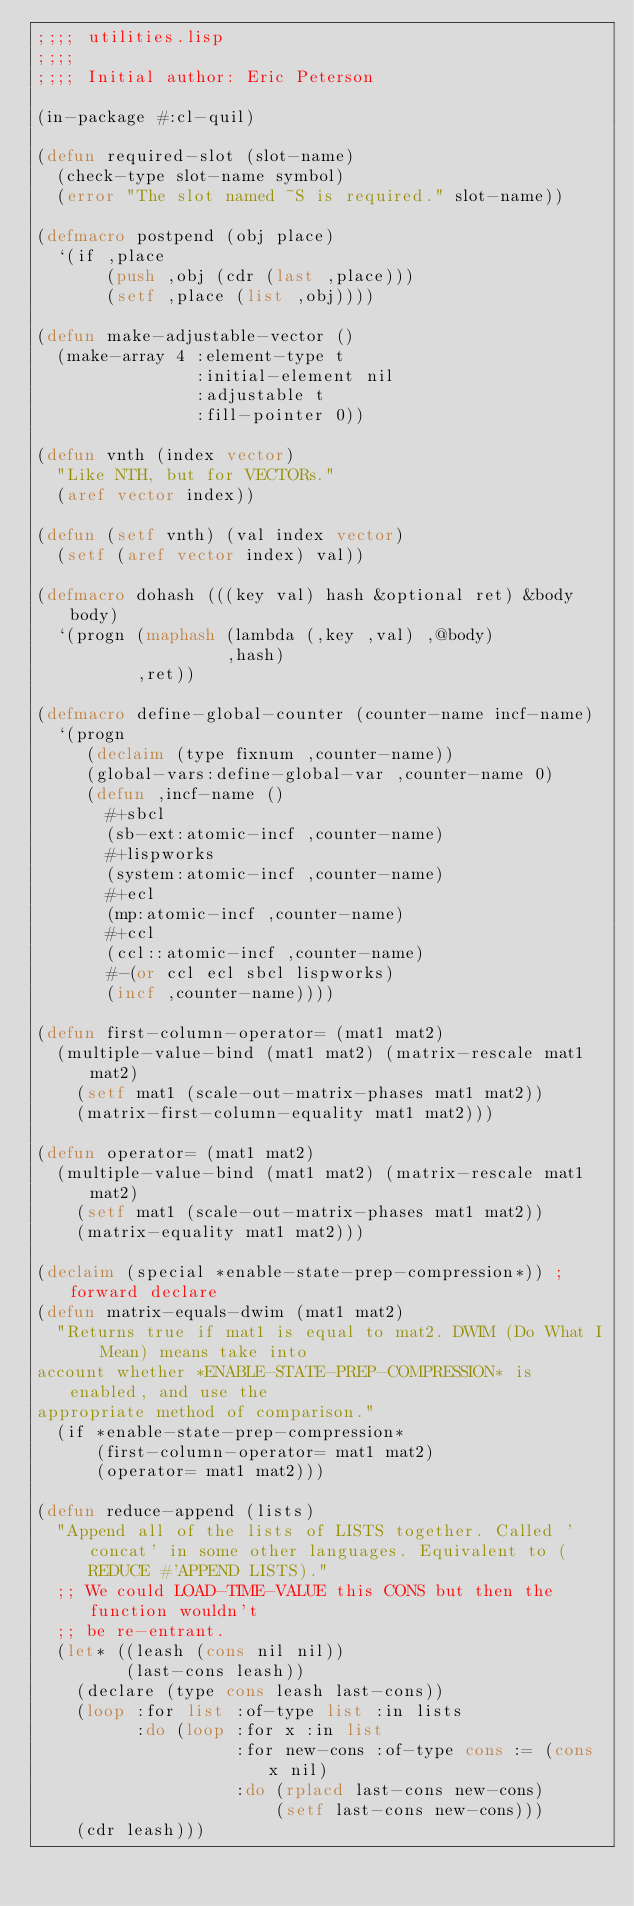<code> <loc_0><loc_0><loc_500><loc_500><_Lisp_>;;;; utilities.lisp
;;;;
;;;; Initial author: Eric Peterson

(in-package #:cl-quil)

(defun required-slot (slot-name)
  (check-type slot-name symbol)
  (error "The slot named ~S is required." slot-name))

(defmacro postpend (obj place)
  `(if ,place
       (push ,obj (cdr (last ,place)))
       (setf ,place (list ,obj))))

(defun make-adjustable-vector ()
  (make-array 4 :element-type t
                :initial-element nil
                :adjustable t
                :fill-pointer 0))

(defun vnth (index vector)
  "Like NTH, but for VECTORs."
  (aref vector index))

(defun (setf vnth) (val index vector)
  (setf (aref vector index) val))

(defmacro dohash (((key val) hash &optional ret) &body body)
  `(progn (maphash (lambda (,key ,val) ,@body)
                   ,hash)
          ,ret))

(defmacro define-global-counter (counter-name incf-name)
  `(progn
     (declaim (type fixnum ,counter-name))
     (global-vars:define-global-var ,counter-name 0)
     (defun ,incf-name ()
       #+sbcl
       (sb-ext:atomic-incf ,counter-name)
       #+lispworks
       (system:atomic-incf ,counter-name)
       #+ecl
       (mp:atomic-incf ,counter-name)
       #+ccl
       (ccl::atomic-incf ,counter-name)
       #-(or ccl ecl sbcl lispworks)
       (incf ,counter-name))))

(defun first-column-operator= (mat1 mat2)
  (multiple-value-bind (mat1 mat2) (matrix-rescale mat1 mat2)
    (setf mat1 (scale-out-matrix-phases mat1 mat2))
    (matrix-first-column-equality mat1 mat2)))

(defun operator= (mat1 mat2)
  (multiple-value-bind (mat1 mat2) (matrix-rescale mat1 mat2)
    (setf mat1 (scale-out-matrix-phases mat1 mat2))
    (matrix-equality mat1 mat2)))

(declaim (special *enable-state-prep-compression*)) ; forward declare
(defun matrix-equals-dwim (mat1 mat2)
  "Returns true if mat1 is equal to mat2. DWIM (Do What I Mean) means take into
account whether *ENABLE-STATE-PREP-COMPRESSION* is enabled, and use the
appropriate method of comparison."
  (if *enable-state-prep-compression*
      (first-column-operator= mat1 mat2)
      (operator= mat1 mat2)))

(defun reduce-append (lists)
  "Append all of the lists of LISTS together. Called 'concat' in some other languages. Equivalent to (REDUCE #'APPEND LISTS)."
  ;; We could LOAD-TIME-VALUE this CONS but then the function wouldn't
  ;; be re-entrant.
  (let* ((leash (cons nil nil))
         (last-cons leash))
    (declare (type cons leash last-cons))
    (loop :for list :of-type list :in lists
          :do (loop :for x :in list
                    :for new-cons :of-type cons := (cons x nil)
                    :do (rplacd last-cons new-cons)
                        (setf last-cons new-cons)))
    (cdr leash)))
</code> 